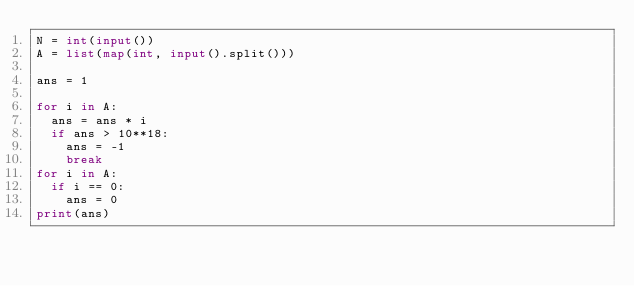Convert code to text. <code><loc_0><loc_0><loc_500><loc_500><_Python_>N = int(input())
A = list(map(int, input().split()))

ans = 1

for i in A:
  ans = ans * i
  if ans > 10**18:
    ans = -1
    break
for i in A:
  if i == 0:
    ans = 0
print(ans)</code> 